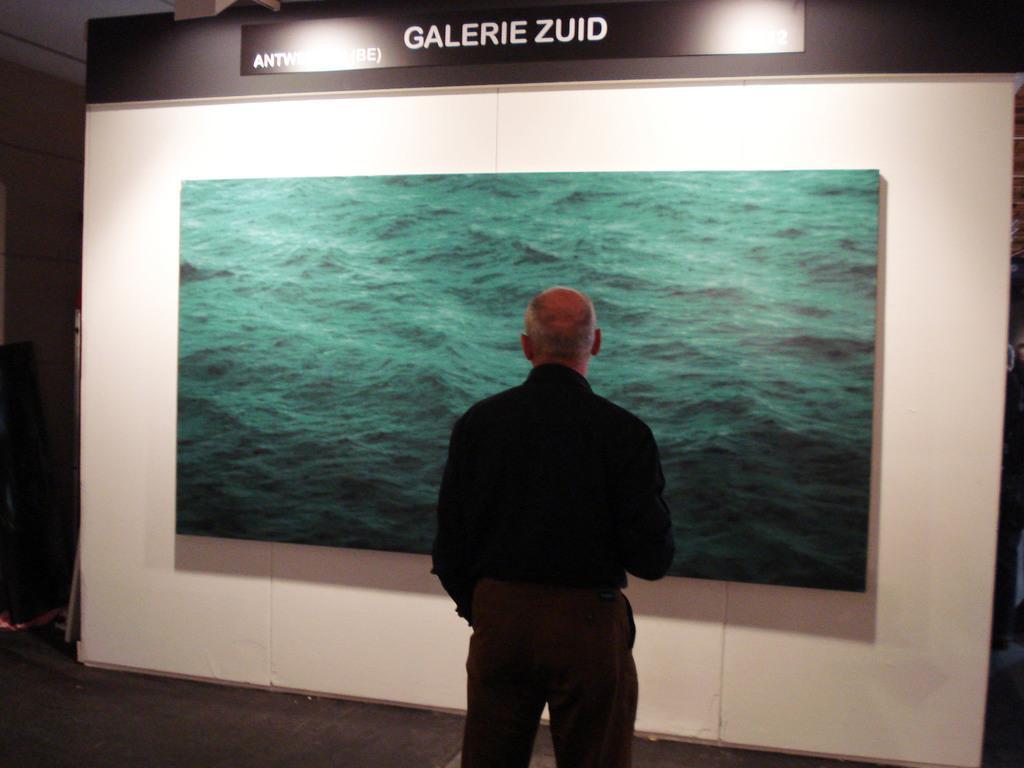Can you describe this image briefly? In this image there is a person standing on a floor, in the background there is a wall for that wall there is a screen, at the top there is text and lights. 